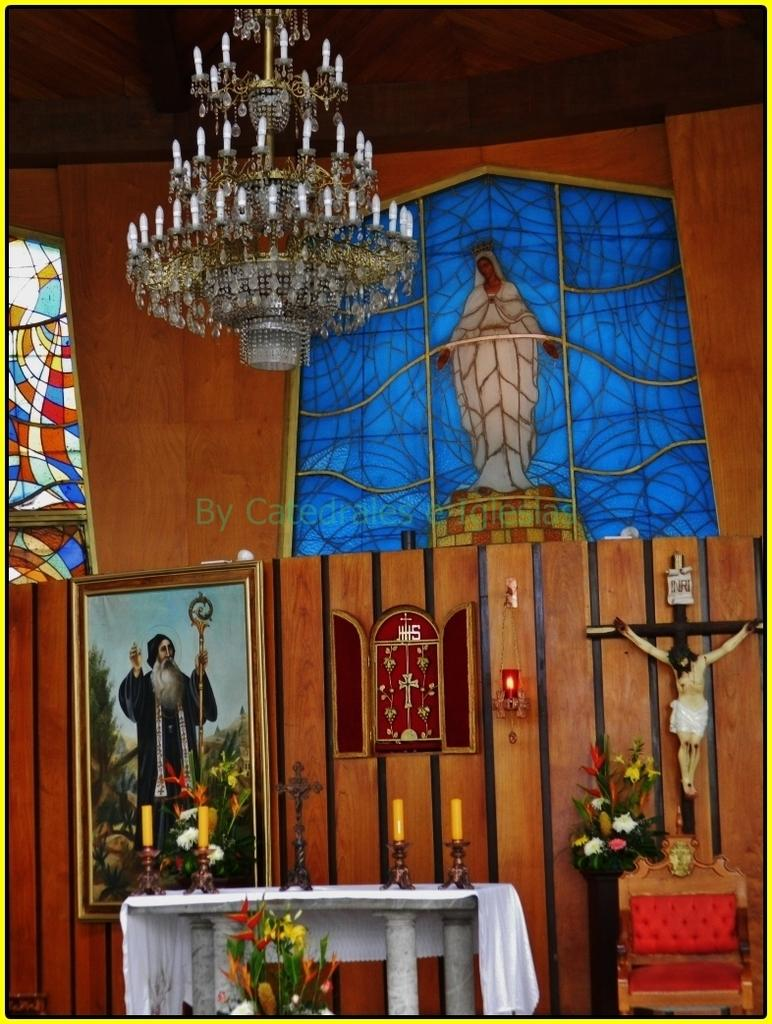What type of lighting fixture is present in the image? There is a chandelier in the image. Where is the chandelier located in relation to the other objects? The chandelier is on top in the image. What is in the middle of the image? There is a table in the middle of the image. What items can be found on the table? There are candles and a flower vase on the table. What type of setting is depicted in the image? The setting appears to be inside a church. What type of beast can be seen roaming around the church in the image? There is no beast present in the image; it depicts a chandelier, table, candles, and a flower vase inside a church. Can you tell me how many apples are on the table in the image? There are no apples present on the table in the image; it has candles and a flower vase. 